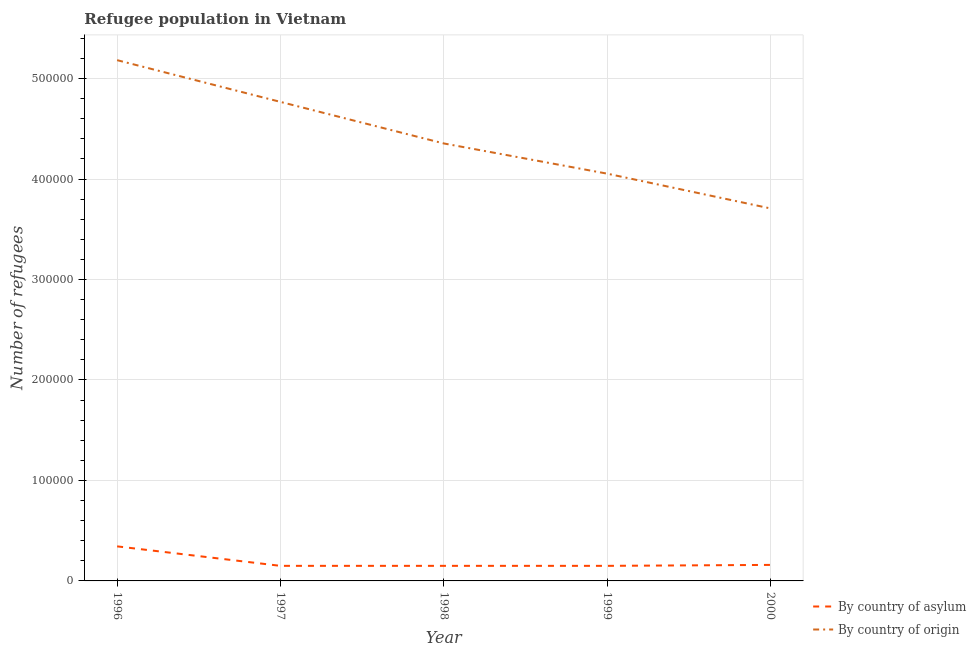Does the line corresponding to number of refugees by country of asylum intersect with the line corresponding to number of refugees by country of origin?
Provide a short and direct response. No. Is the number of lines equal to the number of legend labels?
Provide a short and direct response. Yes. What is the number of refugees by country of origin in 2000?
Offer a terse response. 3.71e+05. Across all years, what is the maximum number of refugees by country of asylum?
Give a very brief answer. 3.44e+04. Across all years, what is the minimum number of refugees by country of origin?
Provide a succinct answer. 3.71e+05. What is the total number of refugees by country of asylum in the graph?
Ensure brevity in your answer.  9.53e+04. What is the difference between the number of refugees by country of origin in 1997 and that in 1999?
Offer a very short reply. 7.14e+04. What is the difference between the number of refugees by country of origin in 1996 and the number of refugees by country of asylum in 2000?
Offer a terse response. 5.02e+05. What is the average number of refugees by country of asylum per year?
Give a very brief answer. 1.91e+04. In the year 2000, what is the difference between the number of refugees by country of origin and number of refugees by country of asylum?
Ensure brevity in your answer.  3.55e+05. In how many years, is the number of refugees by country of asylum greater than 60000?
Provide a short and direct response. 0. What is the ratio of the number of refugees by country of origin in 1997 to that in 2000?
Your answer should be compact. 1.29. Is the number of refugees by country of origin in 1997 less than that in 1998?
Keep it short and to the point. No. What is the difference between the highest and the second highest number of refugees by country of origin?
Offer a very short reply. 4.15e+04. What is the difference between the highest and the lowest number of refugees by country of origin?
Provide a succinct answer. 1.48e+05. In how many years, is the number of refugees by country of asylum greater than the average number of refugees by country of asylum taken over all years?
Offer a terse response. 1. Is the sum of the number of refugees by country of asylum in 1996 and 1997 greater than the maximum number of refugees by country of origin across all years?
Offer a terse response. No. Is the number of refugees by country of asylum strictly less than the number of refugees by country of origin over the years?
Offer a terse response. Yes. How many years are there in the graph?
Give a very brief answer. 5. What is the difference between two consecutive major ticks on the Y-axis?
Offer a very short reply. 1.00e+05. Does the graph contain any zero values?
Give a very brief answer. No. Does the graph contain grids?
Give a very brief answer. Yes. How many legend labels are there?
Provide a succinct answer. 2. How are the legend labels stacked?
Your response must be concise. Vertical. What is the title of the graph?
Your answer should be very brief. Refugee population in Vietnam. Does "Crop" appear as one of the legend labels in the graph?
Offer a terse response. No. What is the label or title of the X-axis?
Offer a terse response. Year. What is the label or title of the Y-axis?
Your answer should be very brief. Number of refugees. What is the Number of refugees in By country of asylum in 1996?
Offer a very short reply. 3.44e+04. What is the Number of refugees in By country of origin in 1996?
Offer a terse response. 5.18e+05. What is the Number of refugees of By country of asylum in 1997?
Offer a very short reply. 1.50e+04. What is the Number of refugees of By country of origin in 1997?
Your answer should be very brief. 4.77e+05. What is the Number of refugees in By country of asylum in 1998?
Make the answer very short. 1.50e+04. What is the Number of refugees in By country of origin in 1998?
Offer a terse response. 4.35e+05. What is the Number of refugees of By country of asylum in 1999?
Ensure brevity in your answer.  1.50e+04. What is the Number of refugees of By country of origin in 1999?
Provide a succinct answer. 4.05e+05. What is the Number of refugees of By country of asylum in 2000?
Keep it short and to the point. 1.59e+04. What is the Number of refugees in By country of origin in 2000?
Make the answer very short. 3.71e+05. Across all years, what is the maximum Number of refugees in By country of asylum?
Ensure brevity in your answer.  3.44e+04. Across all years, what is the maximum Number of refugees of By country of origin?
Keep it short and to the point. 5.18e+05. Across all years, what is the minimum Number of refugees in By country of asylum?
Ensure brevity in your answer.  1.50e+04. Across all years, what is the minimum Number of refugees of By country of origin?
Give a very brief answer. 3.71e+05. What is the total Number of refugees in By country of asylum in the graph?
Provide a succinct answer. 9.53e+04. What is the total Number of refugees of By country of origin in the graph?
Make the answer very short. 2.21e+06. What is the difference between the Number of refugees in By country of asylum in 1996 and that in 1997?
Give a very brief answer. 1.94e+04. What is the difference between the Number of refugees in By country of origin in 1996 and that in 1997?
Your answer should be compact. 4.15e+04. What is the difference between the Number of refugees of By country of asylum in 1996 and that in 1998?
Give a very brief answer. 1.94e+04. What is the difference between the Number of refugees in By country of origin in 1996 and that in 1998?
Offer a very short reply. 8.29e+04. What is the difference between the Number of refugees of By country of asylum in 1996 and that in 1999?
Your response must be concise. 1.94e+04. What is the difference between the Number of refugees of By country of origin in 1996 and that in 1999?
Make the answer very short. 1.13e+05. What is the difference between the Number of refugees of By country of asylum in 1996 and that in 2000?
Keep it short and to the point. 1.85e+04. What is the difference between the Number of refugees in By country of origin in 1996 and that in 2000?
Ensure brevity in your answer.  1.48e+05. What is the difference between the Number of refugees of By country of asylum in 1997 and that in 1998?
Provide a succinct answer. 0. What is the difference between the Number of refugees of By country of origin in 1997 and that in 1998?
Provide a succinct answer. 4.14e+04. What is the difference between the Number of refugees of By country of origin in 1997 and that in 1999?
Give a very brief answer. 7.14e+04. What is the difference between the Number of refugees in By country of asylum in 1997 and that in 2000?
Provide a succinct answer. -945. What is the difference between the Number of refugees of By country of origin in 1997 and that in 2000?
Offer a terse response. 1.06e+05. What is the difference between the Number of refugees of By country of asylum in 1998 and that in 1999?
Give a very brief answer. 0. What is the difference between the Number of refugees of By country of origin in 1998 and that in 1999?
Ensure brevity in your answer.  3.01e+04. What is the difference between the Number of refugees of By country of asylum in 1998 and that in 2000?
Your response must be concise. -945. What is the difference between the Number of refugees in By country of origin in 1998 and that in 2000?
Offer a terse response. 6.47e+04. What is the difference between the Number of refugees in By country of asylum in 1999 and that in 2000?
Ensure brevity in your answer.  -945. What is the difference between the Number of refugees of By country of origin in 1999 and that in 2000?
Provide a succinct answer. 3.46e+04. What is the difference between the Number of refugees in By country of asylum in 1996 and the Number of refugees in By country of origin in 1997?
Your answer should be very brief. -4.42e+05. What is the difference between the Number of refugees of By country of asylum in 1996 and the Number of refugees of By country of origin in 1998?
Make the answer very short. -4.01e+05. What is the difference between the Number of refugees of By country of asylum in 1996 and the Number of refugees of By country of origin in 1999?
Offer a terse response. -3.71e+05. What is the difference between the Number of refugees of By country of asylum in 1996 and the Number of refugees of By country of origin in 2000?
Your response must be concise. -3.36e+05. What is the difference between the Number of refugees in By country of asylum in 1997 and the Number of refugees in By country of origin in 1998?
Provide a short and direct response. -4.20e+05. What is the difference between the Number of refugees in By country of asylum in 1997 and the Number of refugees in By country of origin in 1999?
Make the answer very short. -3.90e+05. What is the difference between the Number of refugees of By country of asylum in 1997 and the Number of refugees of By country of origin in 2000?
Ensure brevity in your answer.  -3.56e+05. What is the difference between the Number of refugees of By country of asylum in 1998 and the Number of refugees of By country of origin in 1999?
Make the answer very short. -3.90e+05. What is the difference between the Number of refugees in By country of asylum in 1998 and the Number of refugees in By country of origin in 2000?
Give a very brief answer. -3.56e+05. What is the difference between the Number of refugees in By country of asylum in 1999 and the Number of refugees in By country of origin in 2000?
Your response must be concise. -3.56e+05. What is the average Number of refugees of By country of asylum per year?
Offer a very short reply. 1.91e+04. What is the average Number of refugees in By country of origin per year?
Provide a short and direct response. 4.41e+05. In the year 1996, what is the difference between the Number of refugees of By country of asylum and Number of refugees of By country of origin?
Keep it short and to the point. -4.84e+05. In the year 1997, what is the difference between the Number of refugees of By country of asylum and Number of refugees of By country of origin?
Your answer should be very brief. -4.62e+05. In the year 1998, what is the difference between the Number of refugees of By country of asylum and Number of refugees of By country of origin?
Provide a succinct answer. -4.20e+05. In the year 1999, what is the difference between the Number of refugees of By country of asylum and Number of refugees of By country of origin?
Offer a terse response. -3.90e+05. In the year 2000, what is the difference between the Number of refugees of By country of asylum and Number of refugees of By country of origin?
Offer a very short reply. -3.55e+05. What is the ratio of the Number of refugees of By country of asylum in 1996 to that in 1997?
Provide a succinct answer. 2.29. What is the ratio of the Number of refugees in By country of origin in 1996 to that in 1997?
Offer a terse response. 1.09. What is the ratio of the Number of refugees in By country of asylum in 1996 to that in 1998?
Keep it short and to the point. 2.29. What is the ratio of the Number of refugees in By country of origin in 1996 to that in 1998?
Your answer should be compact. 1.19. What is the ratio of the Number of refugees of By country of asylum in 1996 to that in 1999?
Provide a succinct answer. 2.29. What is the ratio of the Number of refugees of By country of origin in 1996 to that in 1999?
Offer a terse response. 1.28. What is the ratio of the Number of refugees of By country of asylum in 1996 to that in 2000?
Offer a very short reply. 2.16. What is the ratio of the Number of refugees in By country of origin in 1996 to that in 2000?
Give a very brief answer. 1.4. What is the ratio of the Number of refugees of By country of origin in 1997 to that in 1998?
Your answer should be compact. 1.09. What is the ratio of the Number of refugees in By country of asylum in 1997 to that in 1999?
Make the answer very short. 1. What is the ratio of the Number of refugees of By country of origin in 1997 to that in 1999?
Make the answer very short. 1.18. What is the ratio of the Number of refugees of By country of asylum in 1997 to that in 2000?
Keep it short and to the point. 0.94. What is the ratio of the Number of refugees of By country of origin in 1997 to that in 2000?
Your answer should be very brief. 1.29. What is the ratio of the Number of refugees in By country of origin in 1998 to that in 1999?
Your answer should be compact. 1.07. What is the ratio of the Number of refugees in By country of asylum in 1998 to that in 2000?
Your response must be concise. 0.94. What is the ratio of the Number of refugees of By country of origin in 1998 to that in 2000?
Offer a very short reply. 1.17. What is the ratio of the Number of refugees of By country of asylum in 1999 to that in 2000?
Give a very brief answer. 0.94. What is the ratio of the Number of refugees in By country of origin in 1999 to that in 2000?
Give a very brief answer. 1.09. What is the difference between the highest and the second highest Number of refugees of By country of asylum?
Make the answer very short. 1.85e+04. What is the difference between the highest and the second highest Number of refugees of By country of origin?
Your answer should be very brief. 4.15e+04. What is the difference between the highest and the lowest Number of refugees of By country of asylum?
Offer a terse response. 1.94e+04. What is the difference between the highest and the lowest Number of refugees of By country of origin?
Your response must be concise. 1.48e+05. 